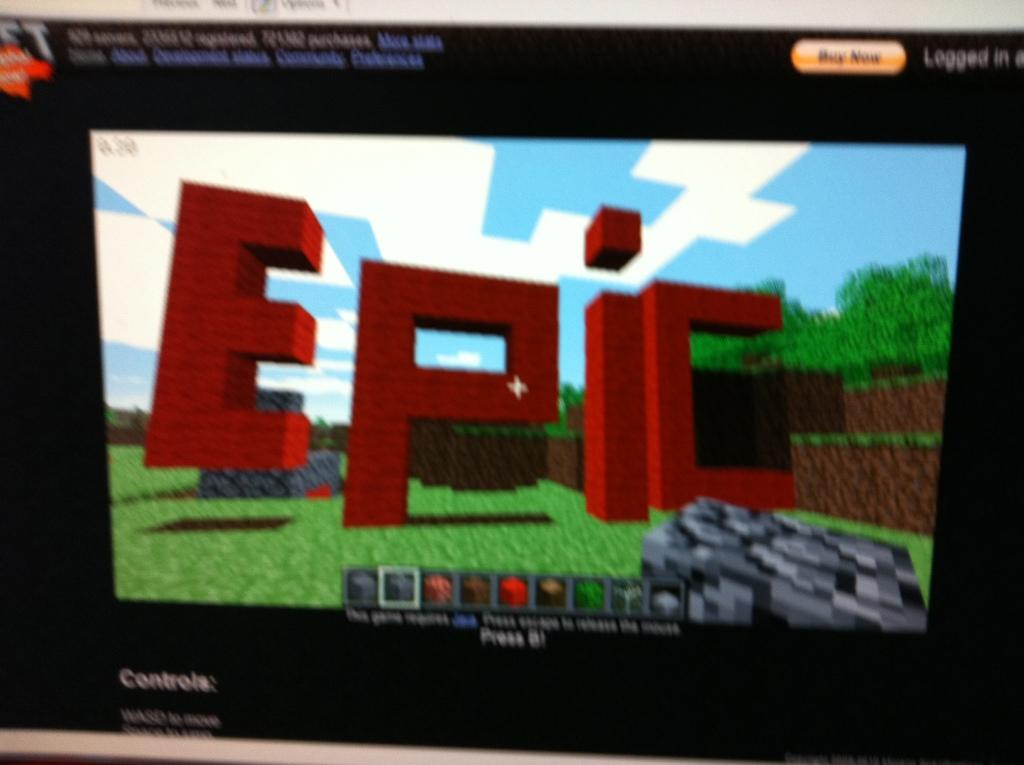<image>
Relay a brief, clear account of the picture shown. a screen showing minecraft game with the word 'epic' on it 